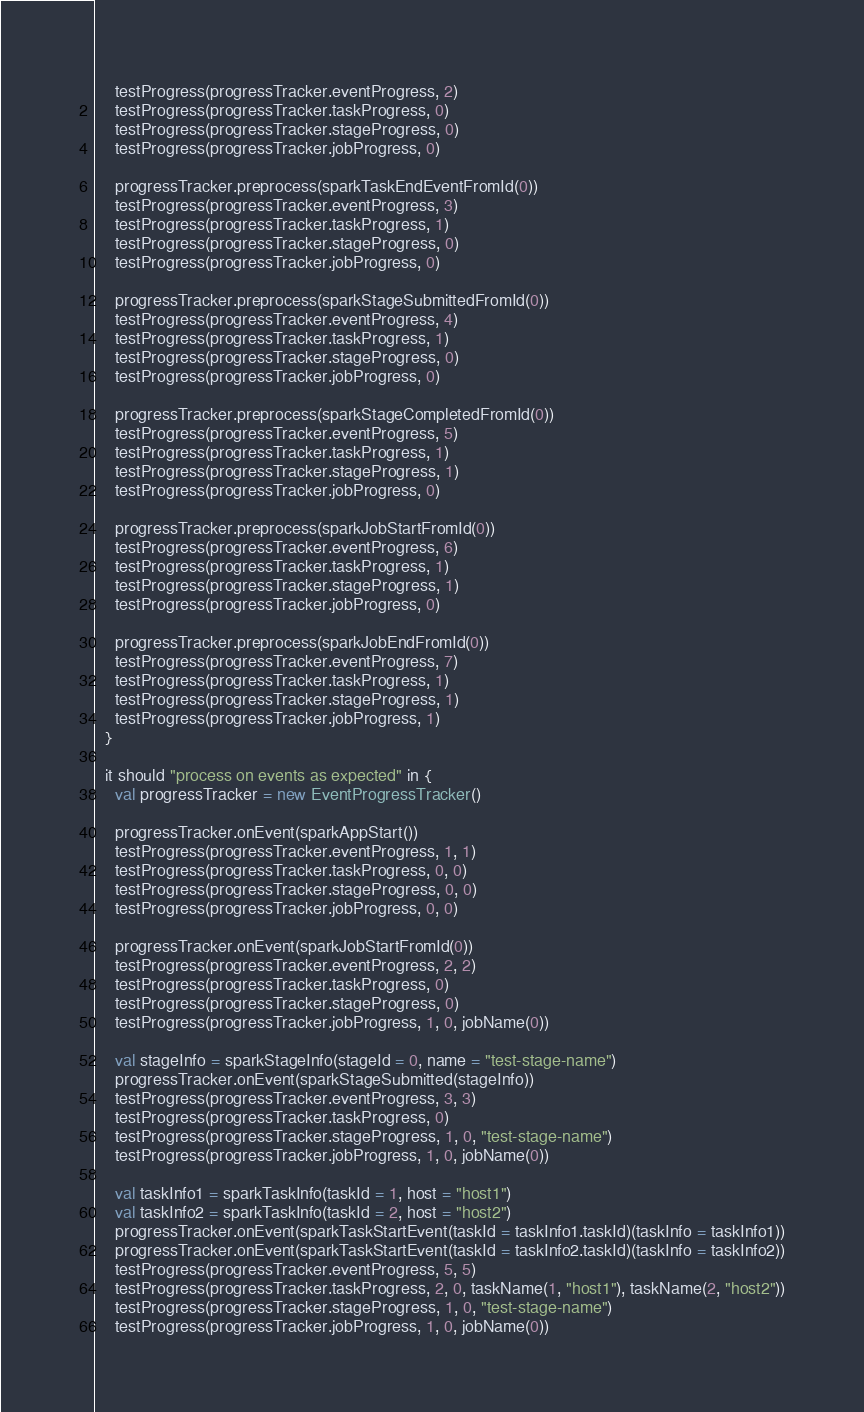Convert code to text. <code><loc_0><loc_0><loc_500><loc_500><_Scala_>    testProgress(progressTracker.eventProgress, 2)
    testProgress(progressTracker.taskProgress, 0)
    testProgress(progressTracker.stageProgress, 0)
    testProgress(progressTracker.jobProgress, 0)

    progressTracker.preprocess(sparkTaskEndEventFromId(0))
    testProgress(progressTracker.eventProgress, 3)
    testProgress(progressTracker.taskProgress, 1)
    testProgress(progressTracker.stageProgress, 0)
    testProgress(progressTracker.jobProgress, 0)

    progressTracker.preprocess(sparkStageSubmittedFromId(0))
    testProgress(progressTracker.eventProgress, 4)
    testProgress(progressTracker.taskProgress, 1)
    testProgress(progressTracker.stageProgress, 0)
    testProgress(progressTracker.jobProgress, 0)

    progressTracker.preprocess(sparkStageCompletedFromId(0))
    testProgress(progressTracker.eventProgress, 5)
    testProgress(progressTracker.taskProgress, 1)
    testProgress(progressTracker.stageProgress, 1)
    testProgress(progressTracker.jobProgress, 0)

    progressTracker.preprocess(sparkJobStartFromId(0))
    testProgress(progressTracker.eventProgress, 6)
    testProgress(progressTracker.taskProgress, 1)
    testProgress(progressTracker.stageProgress, 1)
    testProgress(progressTracker.jobProgress, 0)

    progressTracker.preprocess(sparkJobEndFromId(0))
    testProgress(progressTracker.eventProgress, 7)
    testProgress(progressTracker.taskProgress, 1)
    testProgress(progressTracker.stageProgress, 1)
    testProgress(progressTracker.jobProgress, 1)
  }

  it should "process on events as expected" in {
    val progressTracker = new EventProgressTracker()

    progressTracker.onEvent(sparkAppStart())
    testProgress(progressTracker.eventProgress, 1, 1)
    testProgress(progressTracker.taskProgress, 0, 0)
    testProgress(progressTracker.stageProgress, 0, 0)
    testProgress(progressTracker.jobProgress, 0, 0)

    progressTracker.onEvent(sparkJobStartFromId(0))
    testProgress(progressTracker.eventProgress, 2, 2)
    testProgress(progressTracker.taskProgress, 0)
    testProgress(progressTracker.stageProgress, 0)
    testProgress(progressTracker.jobProgress, 1, 0, jobName(0))

    val stageInfo = sparkStageInfo(stageId = 0, name = "test-stage-name")
    progressTracker.onEvent(sparkStageSubmitted(stageInfo))
    testProgress(progressTracker.eventProgress, 3, 3)
    testProgress(progressTracker.taskProgress, 0)
    testProgress(progressTracker.stageProgress, 1, 0, "test-stage-name")
    testProgress(progressTracker.jobProgress, 1, 0, jobName(0))

    val taskInfo1 = sparkTaskInfo(taskId = 1, host = "host1")
    val taskInfo2 = sparkTaskInfo(taskId = 2, host = "host2")
    progressTracker.onEvent(sparkTaskStartEvent(taskId = taskInfo1.taskId)(taskInfo = taskInfo1))
    progressTracker.onEvent(sparkTaskStartEvent(taskId = taskInfo2.taskId)(taskInfo = taskInfo2))
    testProgress(progressTracker.eventProgress, 5, 5)
    testProgress(progressTracker.taskProgress, 2, 0, taskName(1, "host1"), taskName(2, "host2"))
    testProgress(progressTracker.stageProgress, 1, 0, "test-stage-name")
    testProgress(progressTracker.jobProgress, 1, 0, jobName(0))
</code> 